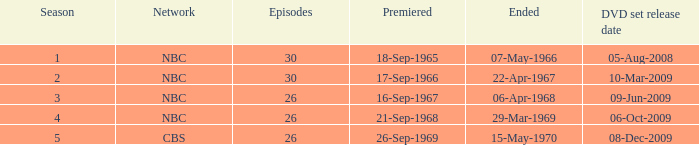When did cbs release the dvd collection? 08-Dec-2009. 